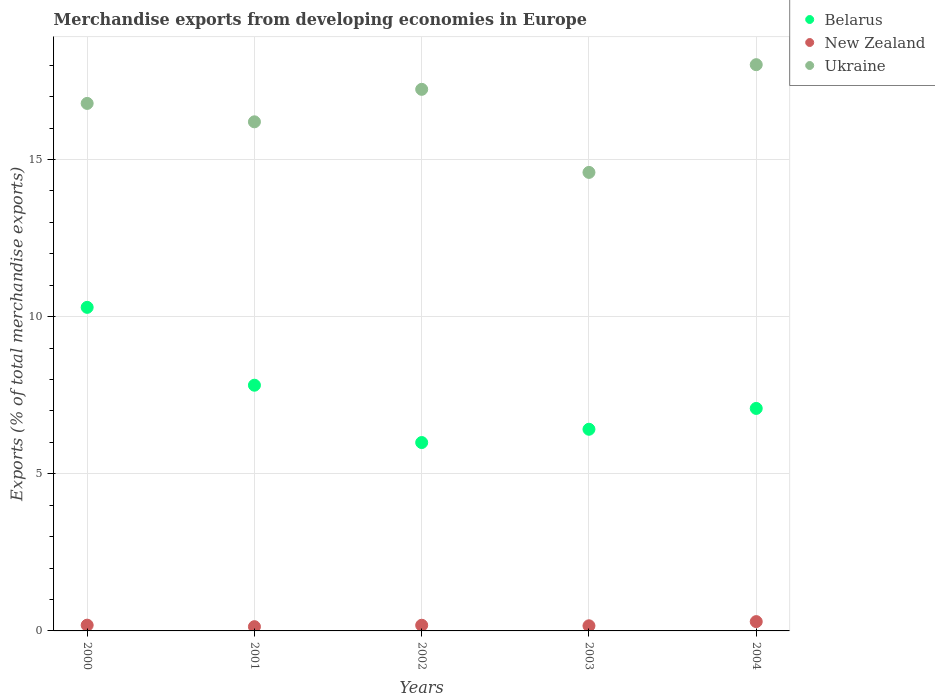How many different coloured dotlines are there?
Keep it short and to the point. 3. What is the percentage of total merchandise exports in Ukraine in 2001?
Ensure brevity in your answer.  16.2. Across all years, what is the maximum percentage of total merchandise exports in Belarus?
Make the answer very short. 10.29. Across all years, what is the minimum percentage of total merchandise exports in New Zealand?
Your answer should be compact. 0.13. In which year was the percentage of total merchandise exports in Belarus minimum?
Provide a succinct answer. 2002. What is the total percentage of total merchandise exports in Ukraine in the graph?
Keep it short and to the point. 82.82. What is the difference between the percentage of total merchandise exports in Belarus in 2000 and that in 2003?
Keep it short and to the point. 3.88. What is the difference between the percentage of total merchandise exports in Belarus in 2002 and the percentage of total merchandise exports in New Zealand in 2003?
Make the answer very short. 5.83. What is the average percentage of total merchandise exports in Ukraine per year?
Offer a very short reply. 16.56. In the year 2004, what is the difference between the percentage of total merchandise exports in Ukraine and percentage of total merchandise exports in Belarus?
Make the answer very short. 10.94. In how many years, is the percentage of total merchandise exports in Ukraine greater than 11 %?
Ensure brevity in your answer.  5. What is the ratio of the percentage of total merchandise exports in Belarus in 2000 to that in 2003?
Offer a terse response. 1.6. Is the percentage of total merchandise exports in Ukraine in 2000 less than that in 2001?
Offer a very short reply. No. What is the difference between the highest and the second highest percentage of total merchandise exports in New Zealand?
Keep it short and to the point. 0.11. What is the difference between the highest and the lowest percentage of total merchandise exports in Ukraine?
Your answer should be compact. 3.43. In how many years, is the percentage of total merchandise exports in Belarus greater than the average percentage of total merchandise exports in Belarus taken over all years?
Keep it short and to the point. 2. Is the sum of the percentage of total merchandise exports in New Zealand in 2001 and 2002 greater than the maximum percentage of total merchandise exports in Ukraine across all years?
Provide a succinct answer. No. Does the percentage of total merchandise exports in Belarus monotonically increase over the years?
Ensure brevity in your answer.  No. Is the percentage of total merchandise exports in New Zealand strictly greater than the percentage of total merchandise exports in Belarus over the years?
Your answer should be compact. No. What is the difference between two consecutive major ticks on the Y-axis?
Keep it short and to the point. 5. Does the graph contain any zero values?
Make the answer very short. No. Does the graph contain grids?
Provide a succinct answer. Yes. Where does the legend appear in the graph?
Your answer should be very brief. Top right. How are the legend labels stacked?
Ensure brevity in your answer.  Vertical. What is the title of the graph?
Your answer should be very brief. Merchandise exports from developing economies in Europe. What is the label or title of the X-axis?
Your answer should be compact. Years. What is the label or title of the Y-axis?
Your answer should be very brief. Exports (% of total merchandise exports). What is the Exports (% of total merchandise exports) in Belarus in 2000?
Offer a very short reply. 10.29. What is the Exports (% of total merchandise exports) in New Zealand in 2000?
Provide a succinct answer. 0.18. What is the Exports (% of total merchandise exports) of Ukraine in 2000?
Provide a succinct answer. 16.78. What is the Exports (% of total merchandise exports) in Belarus in 2001?
Offer a very short reply. 7.82. What is the Exports (% of total merchandise exports) in New Zealand in 2001?
Provide a short and direct response. 0.13. What is the Exports (% of total merchandise exports) of Ukraine in 2001?
Provide a succinct answer. 16.2. What is the Exports (% of total merchandise exports) of Belarus in 2002?
Your answer should be very brief. 5.99. What is the Exports (% of total merchandise exports) in New Zealand in 2002?
Your answer should be compact. 0.18. What is the Exports (% of total merchandise exports) of Ukraine in 2002?
Your answer should be compact. 17.23. What is the Exports (% of total merchandise exports) of Belarus in 2003?
Keep it short and to the point. 6.42. What is the Exports (% of total merchandise exports) in New Zealand in 2003?
Provide a short and direct response. 0.16. What is the Exports (% of total merchandise exports) in Ukraine in 2003?
Your response must be concise. 14.59. What is the Exports (% of total merchandise exports) in Belarus in 2004?
Make the answer very short. 7.08. What is the Exports (% of total merchandise exports) in New Zealand in 2004?
Offer a very short reply. 0.3. What is the Exports (% of total merchandise exports) in Ukraine in 2004?
Your answer should be very brief. 18.02. Across all years, what is the maximum Exports (% of total merchandise exports) in Belarus?
Make the answer very short. 10.29. Across all years, what is the maximum Exports (% of total merchandise exports) of New Zealand?
Give a very brief answer. 0.3. Across all years, what is the maximum Exports (% of total merchandise exports) in Ukraine?
Offer a terse response. 18.02. Across all years, what is the minimum Exports (% of total merchandise exports) of Belarus?
Your answer should be compact. 5.99. Across all years, what is the minimum Exports (% of total merchandise exports) in New Zealand?
Provide a succinct answer. 0.13. Across all years, what is the minimum Exports (% of total merchandise exports) in Ukraine?
Give a very brief answer. 14.59. What is the total Exports (% of total merchandise exports) of Belarus in the graph?
Your answer should be compact. 37.6. What is the total Exports (% of total merchandise exports) of New Zealand in the graph?
Ensure brevity in your answer.  0.96. What is the total Exports (% of total merchandise exports) in Ukraine in the graph?
Make the answer very short. 82.82. What is the difference between the Exports (% of total merchandise exports) in Belarus in 2000 and that in 2001?
Make the answer very short. 2.48. What is the difference between the Exports (% of total merchandise exports) of New Zealand in 2000 and that in 2001?
Give a very brief answer. 0.05. What is the difference between the Exports (% of total merchandise exports) of Ukraine in 2000 and that in 2001?
Ensure brevity in your answer.  0.59. What is the difference between the Exports (% of total merchandise exports) of Belarus in 2000 and that in 2002?
Ensure brevity in your answer.  4.3. What is the difference between the Exports (% of total merchandise exports) in New Zealand in 2000 and that in 2002?
Provide a short and direct response. 0. What is the difference between the Exports (% of total merchandise exports) of Ukraine in 2000 and that in 2002?
Ensure brevity in your answer.  -0.45. What is the difference between the Exports (% of total merchandise exports) of Belarus in 2000 and that in 2003?
Make the answer very short. 3.88. What is the difference between the Exports (% of total merchandise exports) in New Zealand in 2000 and that in 2003?
Your response must be concise. 0.02. What is the difference between the Exports (% of total merchandise exports) of Ukraine in 2000 and that in 2003?
Offer a very short reply. 2.2. What is the difference between the Exports (% of total merchandise exports) in Belarus in 2000 and that in 2004?
Give a very brief answer. 3.22. What is the difference between the Exports (% of total merchandise exports) in New Zealand in 2000 and that in 2004?
Offer a terse response. -0.11. What is the difference between the Exports (% of total merchandise exports) of Ukraine in 2000 and that in 2004?
Ensure brevity in your answer.  -1.23. What is the difference between the Exports (% of total merchandise exports) of Belarus in 2001 and that in 2002?
Your response must be concise. 1.82. What is the difference between the Exports (% of total merchandise exports) in New Zealand in 2001 and that in 2002?
Offer a terse response. -0.05. What is the difference between the Exports (% of total merchandise exports) of Ukraine in 2001 and that in 2002?
Give a very brief answer. -1.03. What is the difference between the Exports (% of total merchandise exports) in Belarus in 2001 and that in 2003?
Keep it short and to the point. 1.4. What is the difference between the Exports (% of total merchandise exports) in New Zealand in 2001 and that in 2003?
Ensure brevity in your answer.  -0.03. What is the difference between the Exports (% of total merchandise exports) of Ukraine in 2001 and that in 2003?
Ensure brevity in your answer.  1.61. What is the difference between the Exports (% of total merchandise exports) in Belarus in 2001 and that in 2004?
Make the answer very short. 0.74. What is the difference between the Exports (% of total merchandise exports) in New Zealand in 2001 and that in 2004?
Offer a terse response. -0.16. What is the difference between the Exports (% of total merchandise exports) in Ukraine in 2001 and that in 2004?
Provide a succinct answer. -1.82. What is the difference between the Exports (% of total merchandise exports) in Belarus in 2002 and that in 2003?
Keep it short and to the point. -0.42. What is the difference between the Exports (% of total merchandise exports) of New Zealand in 2002 and that in 2003?
Keep it short and to the point. 0.02. What is the difference between the Exports (% of total merchandise exports) of Ukraine in 2002 and that in 2003?
Your response must be concise. 2.64. What is the difference between the Exports (% of total merchandise exports) in Belarus in 2002 and that in 2004?
Your answer should be very brief. -1.09. What is the difference between the Exports (% of total merchandise exports) of New Zealand in 2002 and that in 2004?
Your response must be concise. -0.12. What is the difference between the Exports (% of total merchandise exports) in Ukraine in 2002 and that in 2004?
Keep it short and to the point. -0.78. What is the difference between the Exports (% of total merchandise exports) in Belarus in 2003 and that in 2004?
Your response must be concise. -0.66. What is the difference between the Exports (% of total merchandise exports) of New Zealand in 2003 and that in 2004?
Your answer should be very brief. -0.13. What is the difference between the Exports (% of total merchandise exports) of Ukraine in 2003 and that in 2004?
Provide a short and direct response. -3.43. What is the difference between the Exports (% of total merchandise exports) in Belarus in 2000 and the Exports (% of total merchandise exports) in New Zealand in 2001?
Keep it short and to the point. 10.16. What is the difference between the Exports (% of total merchandise exports) of Belarus in 2000 and the Exports (% of total merchandise exports) of Ukraine in 2001?
Keep it short and to the point. -5.9. What is the difference between the Exports (% of total merchandise exports) in New Zealand in 2000 and the Exports (% of total merchandise exports) in Ukraine in 2001?
Provide a succinct answer. -16.01. What is the difference between the Exports (% of total merchandise exports) of Belarus in 2000 and the Exports (% of total merchandise exports) of New Zealand in 2002?
Ensure brevity in your answer.  10.11. What is the difference between the Exports (% of total merchandise exports) in Belarus in 2000 and the Exports (% of total merchandise exports) in Ukraine in 2002?
Provide a succinct answer. -6.94. What is the difference between the Exports (% of total merchandise exports) in New Zealand in 2000 and the Exports (% of total merchandise exports) in Ukraine in 2002?
Offer a very short reply. -17.05. What is the difference between the Exports (% of total merchandise exports) of Belarus in 2000 and the Exports (% of total merchandise exports) of New Zealand in 2003?
Provide a short and direct response. 10.13. What is the difference between the Exports (% of total merchandise exports) in Belarus in 2000 and the Exports (% of total merchandise exports) in Ukraine in 2003?
Ensure brevity in your answer.  -4.29. What is the difference between the Exports (% of total merchandise exports) of New Zealand in 2000 and the Exports (% of total merchandise exports) of Ukraine in 2003?
Your answer should be compact. -14.41. What is the difference between the Exports (% of total merchandise exports) of Belarus in 2000 and the Exports (% of total merchandise exports) of New Zealand in 2004?
Provide a short and direct response. 10. What is the difference between the Exports (% of total merchandise exports) of Belarus in 2000 and the Exports (% of total merchandise exports) of Ukraine in 2004?
Make the answer very short. -7.72. What is the difference between the Exports (% of total merchandise exports) of New Zealand in 2000 and the Exports (% of total merchandise exports) of Ukraine in 2004?
Your answer should be very brief. -17.83. What is the difference between the Exports (% of total merchandise exports) in Belarus in 2001 and the Exports (% of total merchandise exports) in New Zealand in 2002?
Your response must be concise. 7.64. What is the difference between the Exports (% of total merchandise exports) of Belarus in 2001 and the Exports (% of total merchandise exports) of Ukraine in 2002?
Your answer should be very brief. -9.41. What is the difference between the Exports (% of total merchandise exports) of New Zealand in 2001 and the Exports (% of total merchandise exports) of Ukraine in 2002?
Your response must be concise. -17.1. What is the difference between the Exports (% of total merchandise exports) in Belarus in 2001 and the Exports (% of total merchandise exports) in New Zealand in 2003?
Your answer should be very brief. 7.65. What is the difference between the Exports (% of total merchandise exports) of Belarus in 2001 and the Exports (% of total merchandise exports) of Ukraine in 2003?
Your answer should be very brief. -6.77. What is the difference between the Exports (% of total merchandise exports) of New Zealand in 2001 and the Exports (% of total merchandise exports) of Ukraine in 2003?
Make the answer very short. -14.45. What is the difference between the Exports (% of total merchandise exports) in Belarus in 2001 and the Exports (% of total merchandise exports) in New Zealand in 2004?
Offer a very short reply. 7.52. What is the difference between the Exports (% of total merchandise exports) of Belarus in 2001 and the Exports (% of total merchandise exports) of Ukraine in 2004?
Your response must be concise. -10.2. What is the difference between the Exports (% of total merchandise exports) of New Zealand in 2001 and the Exports (% of total merchandise exports) of Ukraine in 2004?
Keep it short and to the point. -17.88. What is the difference between the Exports (% of total merchandise exports) in Belarus in 2002 and the Exports (% of total merchandise exports) in New Zealand in 2003?
Ensure brevity in your answer.  5.83. What is the difference between the Exports (% of total merchandise exports) in Belarus in 2002 and the Exports (% of total merchandise exports) in Ukraine in 2003?
Your response must be concise. -8.6. What is the difference between the Exports (% of total merchandise exports) of New Zealand in 2002 and the Exports (% of total merchandise exports) of Ukraine in 2003?
Your answer should be compact. -14.41. What is the difference between the Exports (% of total merchandise exports) in Belarus in 2002 and the Exports (% of total merchandise exports) in New Zealand in 2004?
Ensure brevity in your answer.  5.7. What is the difference between the Exports (% of total merchandise exports) in Belarus in 2002 and the Exports (% of total merchandise exports) in Ukraine in 2004?
Your answer should be compact. -12.02. What is the difference between the Exports (% of total merchandise exports) in New Zealand in 2002 and the Exports (% of total merchandise exports) in Ukraine in 2004?
Offer a terse response. -17.84. What is the difference between the Exports (% of total merchandise exports) in Belarus in 2003 and the Exports (% of total merchandise exports) in New Zealand in 2004?
Your answer should be very brief. 6.12. What is the difference between the Exports (% of total merchandise exports) of Belarus in 2003 and the Exports (% of total merchandise exports) of Ukraine in 2004?
Ensure brevity in your answer.  -11.6. What is the difference between the Exports (% of total merchandise exports) in New Zealand in 2003 and the Exports (% of total merchandise exports) in Ukraine in 2004?
Offer a terse response. -17.85. What is the average Exports (% of total merchandise exports) in Belarus per year?
Your response must be concise. 7.52. What is the average Exports (% of total merchandise exports) in New Zealand per year?
Provide a succinct answer. 0.19. What is the average Exports (% of total merchandise exports) in Ukraine per year?
Offer a terse response. 16.56. In the year 2000, what is the difference between the Exports (% of total merchandise exports) in Belarus and Exports (% of total merchandise exports) in New Zealand?
Your answer should be very brief. 10.11. In the year 2000, what is the difference between the Exports (% of total merchandise exports) in Belarus and Exports (% of total merchandise exports) in Ukraine?
Provide a succinct answer. -6.49. In the year 2000, what is the difference between the Exports (% of total merchandise exports) of New Zealand and Exports (% of total merchandise exports) of Ukraine?
Your answer should be compact. -16.6. In the year 2001, what is the difference between the Exports (% of total merchandise exports) in Belarus and Exports (% of total merchandise exports) in New Zealand?
Your answer should be compact. 7.68. In the year 2001, what is the difference between the Exports (% of total merchandise exports) in Belarus and Exports (% of total merchandise exports) in Ukraine?
Offer a very short reply. -8.38. In the year 2001, what is the difference between the Exports (% of total merchandise exports) in New Zealand and Exports (% of total merchandise exports) in Ukraine?
Your response must be concise. -16.06. In the year 2002, what is the difference between the Exports (% of total merchandise exports) of Belarus and Exports (% of total merchandise exports) of New Zealand?
Offer a very short reply. 5.81. In the year 2002, what is the difference between the Exports (% of total merchandise exports) of Belarus and Exports (% of total merchandise exports) of Ukraine?
Provide a short and direct response. -11.24. In the year 2002, what is the difference between the Exports (% of total merchandise exports) of New Zealand and Exports (% of total merchandise exports) of Ukraine?
Make the answer very short. -17.05. In the year 2003, what is the difference between the Exports (% of total merchandise exports) of Belarus and Exports (% of total merchandise exports) of New Zealand?
Your answer should be compact. 6.25. In the year 2003, what is the difference between the Exports (% of total merchandise exports) of Belarus and Exports (% of total merchandise exports) of Ukraine?
Ensure brevity in your answer.  -8.17. In the year 2003, what is the difference between the Exports (% of total merchandise exports) in New Zealand and Exports (% of total merchandise exports) in Ukraine?
Your answer should be very brief. -14.43. In the year 2004, what is the difference between the Exports (% of total merchandise exports) of Belarus and Exports (% of total merchandise exports) of New Zealand?
Provide a succinct answer. 6.78. In the year 2004, what is the difference between the Exports (% of total merchandise exports) of Belarus and Exports (% of total merchandise exports) of Ukraine?
Give a very brief answer. -10.94. In the year 2004, what is the difference between the Exports (% of total merchandise exports) in New Zealand and Exports (% of total merchandise exports) in Ukraine?
Your answer should be very brief. -17.72. What is the ratio of the Exports (% of total merchandise exports) in Belarus in 2000 to that in 2001?
Give a very brief answer. 1.32. What is the ratio of the Exports (% of total merchandise exports) in New Zealand in 2000 to that in 2001?
Make the answer very short. 1.36. What is the ratio of the Exports (% of total merchandise exports) in Ukraine in 2000 to that in 2001?
Offer a very short reply. 1.04. What is the ratio of the Exports (% of total merchandise exports) of Belarus in 2000 to that in 2002?
Offer a very short reply. 1.72. What is the ratio of the Exports (% of total merchandise exports) in New Zealand in 2000 to that in 2002?
Provide a succinct answer. 1.02. What is the ratio of the Exports (% of total merchandise exports) of Belarus in 2000 to that in 2003?
Ensure brevity in your answer.  1.6. What is the ratio of the Exports (% of total merchandise exports) in New Zealand in 2000 to that in 2003?
Your answer should be very brief. 1.12. What is the ratio of the Exports (% of total merchandise exports) of Ukraine in 2000 to that in 2003?
Offer a terse response. 1.15. What is the ratio of the Exports (% of total merchandise exports) of Belarus in 2000 to that in 2004?
Your answer should be compact. 1.45. What is the ratio of the Exports (% of total merchandise exports) in New Zealand in 2000 to that in 2004?
Your response must be concise. 0.62. What is the ratio of the Exports (% of total merchandise exports) in Ukraine in 2000 to that in 2004?
Offer a very short reply. 0.93. What is the ratio of the Exports (% of total merchandise exports) of Belarus in 2001 to that in 2002?
Provide a succinct answer. 1.3. What is the ratio of the Exports (% of total merchandise exports) of New Zealand in 2001 to that in 2002?
Your response must be concise. 0.75. What is the ratio of the Exports (% of total merchandise exports) in Ukraine in 2001 to that in 2002?
Keep it short and to the point. 0.94. What is the ratio of the Exports (% of total merchandise exports) in Belarus in 2001 to that in 2003?
Your answer should be very brief. 1.22. What is the ratio of the Exports (% of total merchandise exports) of New Zealand in 2001 to that in 2003?
Provide a succinct answer. 0.83. What is the ratio of the Exports (% of total merchandise exports) in Ukraine in 2001 to that in 2003?
Your answer should be very brief. 1.11. What is the ratio of the Exports (% of total merchandise exports) of Belarus in 2001 to that in 2004?
Keep it short and to the point. 1.1. What is the ratio of the Exports (% of total merchandise exports) of New Zealand in 2001 to that in 2004?
Give a very brief answer. 0.46. What is the ratio of the Exports (% of total merchandise exports) in Ukraine in 2001 to that in 2004?
Give a very brief answer. 0.9. What is the ratio of the Exports (% of total merchandise exports) of Belarus in 2002 to that in 2003?
Your answer should be compact. 0.93. What is the ratio of the Exports (% of total merchandise exports) in New Zealand in 2002 to that in 2003?
Ensure brevity in your answer.  1.1. What is the ratio of the Exports (% of total merchandise exports) in Ukraine in 2002 to that in 2003?
Ensure brevity in your answer.  1.18. What is the ratio of the Exports (% of total merchandise exports) of Belarus in 2002 to that in 2004?
Provide a short and direct response. 0.85. What is the ratio of the Exports (% of total merchandise exports) in New Zealand in 2002 to that in 2004?
Provide a short and direct response. 0.61. What is the ratio of the Exports (% of total merchandise exports) in Ukraine in 2002 to that in 2004?
Your answer should be very brief. 0.96. What is the ratio of the Exports (% of total merchandise exports) in Belarus in 2003 to that in 2004?
Give a very brief answer. 0.91. What is the ratio of the Exports (% of total merchandise exports) in New Zealand in 2003 to that in 2004?
Your answer should be very brief. 0.55. What is the ratio of the Exports (% of total merchandise exports) in Ukraine in 2003 to that in 2004?
Ensure brevity in your answer.  0.81. What is the difference between the highest and the second highest Exports (% of total merchandise exports) of Belarus?
Offer a very short reply. 2.48. What is the difference between the highest and the second highest Exports (% of total merchandise exports) of New Zealand?
Keep it short and to the point. 0.11. What is the difference between the highest and the second highest Exports (% of total merchandise exports) in Ukraine?
Your answer should be compact. 0.78. What is the difference between the highest and the lowest Exports (% of total merchandise exports) of Belarus?
Your answer should be very brief. 4.3. What is the difference between the highest and the lowest Exports (% of total merchandise exports) of New Zealand?
Your answer should be compact. 0.16. What is the difference between the highest and the lowest Exports (% of total merchandise exports) in Ukraine?
Ensure brevity in your answer.  3.43. 